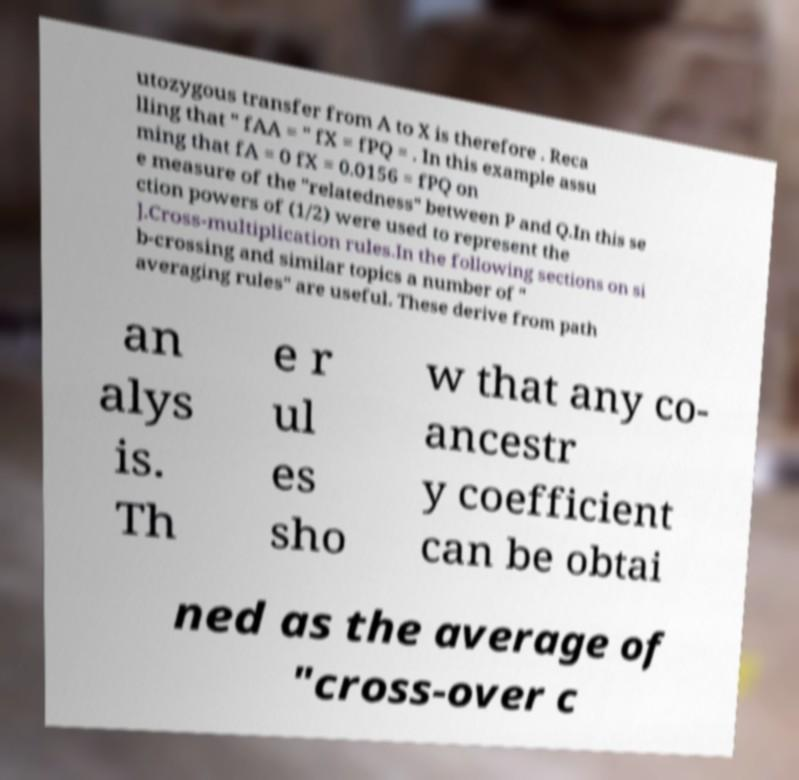For documentation purposes, I need the text within this image transcribed. Could you provide that? utozygous transfer from A to X is therefore . Reca lling that " fAA = " fX = fPQ = . In this example assu ming that fA = 0 fX = 0.0156 = fPQ on e measure of the "relatedness" between P and Q.In this se ction powers of (1/2) were used to represent the ].Cross-multiplication rules.In the following sections on si b-crossing and similar topics a number of " averaging rules" are useful. These derive from path an alys is. Th e r ul es sho w that any co- ancestr y coefficient can be obtai ned as the average of "cross-over c 